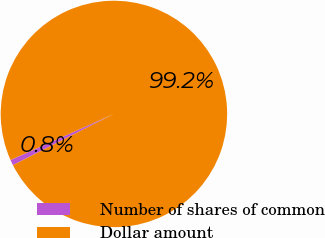Convert chart. <chart><loc_0><loc_0><loc_500><loc_500><pie_chart><fcel>Number of shares of common<fcel>Dollar amount<nl><fcel>0.8%<fcel>99.2%<nl></chart> 